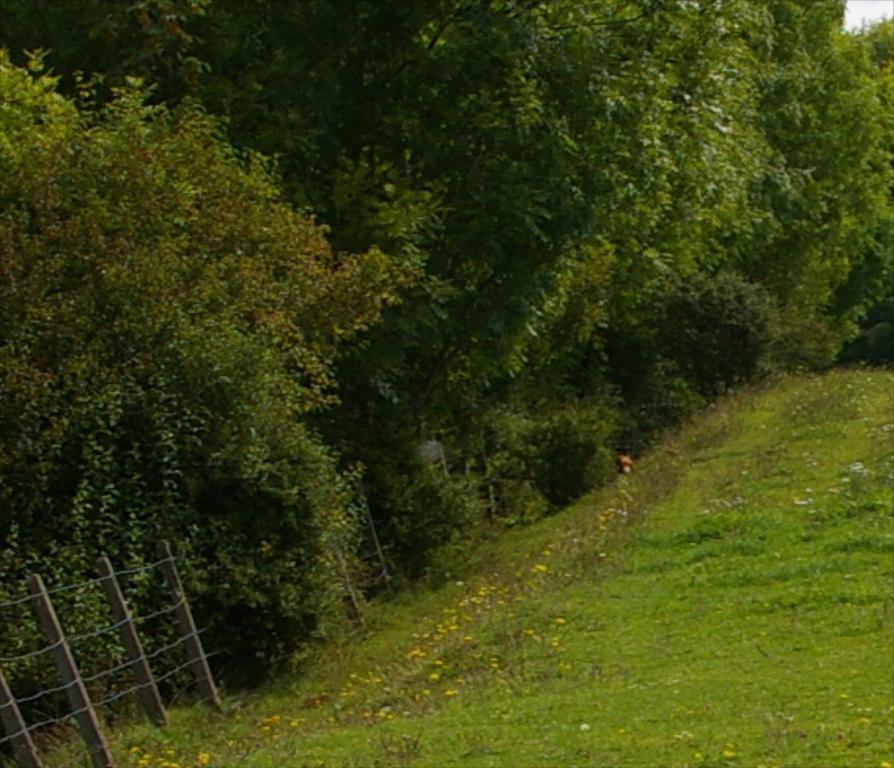In one or two sentences, can you explain what this image depicts? In this image I can see on the left side there is an iron fencing and there are trees. At the bottom there flower plants. 